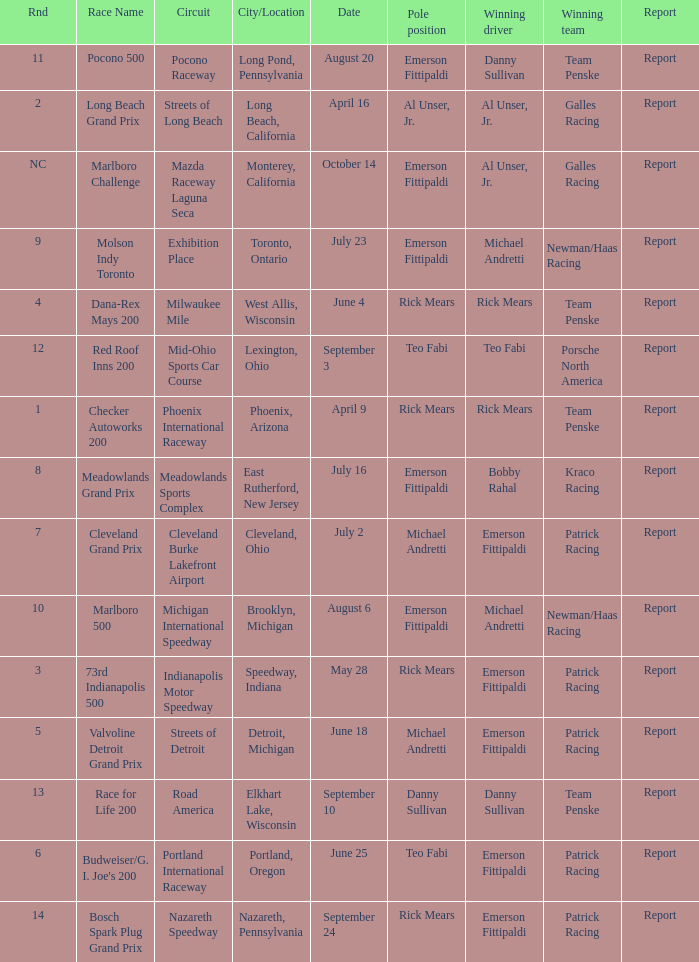Would you be able to parse every entry in this table? {'header': ['Rnd', 'Race Name', 'Circuit', 'City/Location', 'Date', 'Pole position', 'Winning driver', 'Winning team', 'Report'], 'rows': [['11', 'Pocono 500', 'Pocono Raceway', 'Long Pond, Pennsylvania', 'August 20', 'Emerson Fittipaldi', 'Danny Sullivan', 'Team Penske', 'Report'], ['2', 'Long Beach Grand Prix', 'Streets of Long Beach', 'Long Beach, California', 'April 16', 'Al Unser, Jr.', 'Al Unser, Jr.', 'Galles Racing', 'Report'], ['NC', 'Marlboro Challenge', 'Mazda Raceway Laguna Seca', 'Monterey, California', 'October 14', 'Emerson Fittipaldi', 'Al Unser, Jr.', 'Galles Racing', 'Report'], ['9', 'Molson Indy Toronto', 'Exhibition Place', 'Toronto, Ontario', 'July 23', 'Emerson Fittipaldi', 'Michael Andretti', 'Newman/Haas Racing', 'Report'], ['4', 'Dana-Rex Mays 200', 'Milwaukee Mile', 'West Allis, Wisconsin', 'June 4', 'Rick Mears', 'Rick Mears', 'Team Penske', 'Report'], ['12', 'Red Roof Inns 200', 'Mid-Ohio Sports Car Course', 'Lexington, Ohio', 'September 3', 'Teo Fabi', 'Teo Fabi', 'Porsche North America', 'Report'], ['1', 'Checker Autoworks 200', 'Phoenix International Raceway', 'Phoenix, Arizona', 'April 9', 'Rick Mears', 'Rick Mears', 'Team Penske', 'Report'], ['8', 'Meadowlands Grand Prix', 'Meadowlands Sports Complex', 'East Rutherford, New Jersey', 'July 16', 'Emerson Fittipaldi', 'Bobby Rahal', 'Kraco Racing', 'Report'], ['7', 'Cleveland Grand Prix', 'Cleveland Burke Lakefront Airport', 'Cleveland, Ohio', 'July 2', 'Michael Andretti', 'Emerson Fittipaldi', 'Patrick Racing', 'Report'], ['10', 'Marlboro 500', 'Michigan International Speedway', 'Brooklyn, Michigan', 'August 6', 'Emerson Fittipaldi', 'Michael Andretti', 'Newman/Haas Racing', 'Report'], ['3', '73rd Indianapolis 500', 'Indianapolis Motor Speedway', 'Speedway, Indiana', 'May 28', 'Rick Mears', 'Emerson Fittipaldi', 'Patrick Racing', 'Report'], ['5', 'Valvoline Detroit Grand Prix', 'Streets of Detroit', 'Detroit, Michigan', 'June 18', 'Michael Andretti', 'Emerson Fittipaldi', 'Patrick Racing', 'Report'], ['13', 'Race for Life 200', 'Road America', 'Elkhart Lake, Wisconsin', 'September 10', 'Danny Sullivan', 'Danny Sullivan', 'Team Penske', 'Report'], ['6', "Budweiser/G. I. Joe's 200", 'Portland International Raceway', 'Portland, Oregon', 'June 25', 'Teo Fabi', 'Emerson Fittipaldi', 'Patrick Racing', 'Report'], ['14', 'Bosch Spark Plug Grand Prix', 'Nazareth Speedway', 'Nazareth, Pennsylvania', 'September 24', 'Rick Mears', 'Emerson Fittipaldi', 'Patrick Racing', 'Report']]} Who was the pole position for the rnd equalling 12? Teo Fabi. 